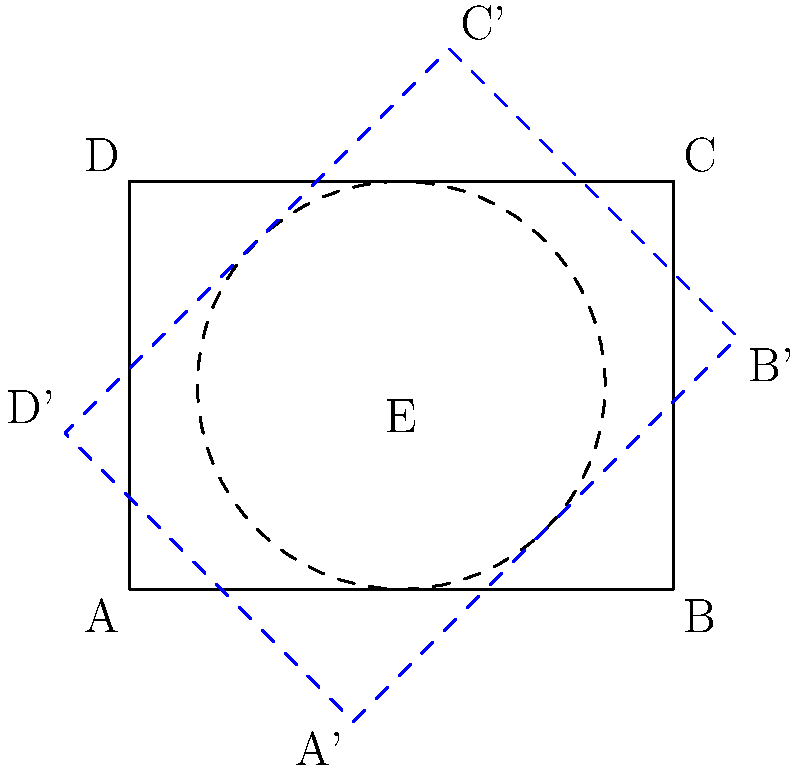A rectangular dance floor ABCD measures 4m by 3m and is currently aligned with the edges of a rooftop venue. To maximize space utilization, you decide to rotate the dance floor around point E, which is at the center of the floor. If you rotate the dance floor by 45°, what is the new area of the venue that the rotated dance floor will occupy? Let's approach this step-by-step:

1) The original dance floor is a 4m by 3m rectangle. Its area is:
   $A = 4m \times 3m = 12m^2$

2) When we rotate the rectangle, it becomes a square that encompasses the original rectangle. This square's diagonal is equal to the diagonal of the original rectangle.

3) To find the diagonal of the original rectangle, we can use the Pythagorean theorem:
   $diagonal^2 = 4^2 + 3^2 = 16 + 9 = 25$
   $diagonal = \sqrt{25} = 5m$

4) This diagonal becomes the side of the new square after rotation. So the area of the new square is:
   $A_{new} = 5m \times 5m = 25m^2$

5) Therefore, the increase in area is:
   $25m^2 - 12m^2 = 13m^2$

The rotated dance floor will occupy 25m² of the venue's area.
Answer: 25m² 